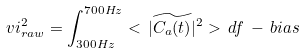Convert formula to latex. <formula><loc_0><loc_0><loc_500><loc_500>\ v i ^ { 2 } _ { r a w } = \int _ { 3 0 0 H z } ^ { 7 0 0 H z } < \, | \widetilde { C _ { a } ( t ) } | ^ { 2 } > \, d f \, - \, b i a s</formula> 